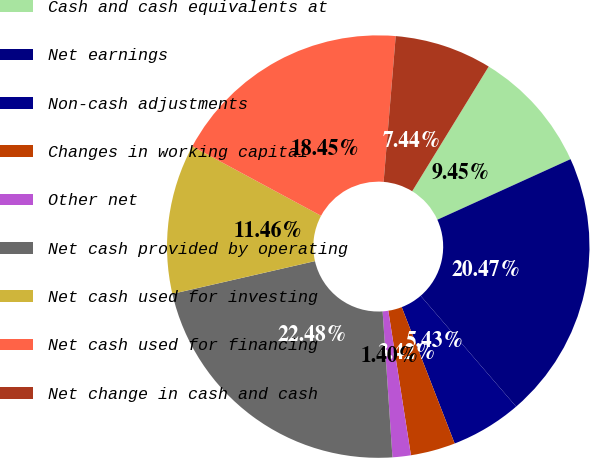Convert chart. <chart><loc_0><loc_0><loc_500><loc_500><pie_chart><fcel>Cash and cash equivalents at<fcel>Net earnings<fcel>Non-cash adjustments<fcel>Changes in working capital<fcel>Other net<fcel>Net cash provided by operating<fcel>Net cash used for investing<fcel>Net cash used for financing<fcel>Net change in cash and cash<nl><fcel>9.45%<fcel>20.47%<fcel>5.43%<fcel>3.42%<fcel>1.4%<fcel>22.48%<fcel>11.46%<fcel>18.45%<fcel>7.44%<nl></chart> 